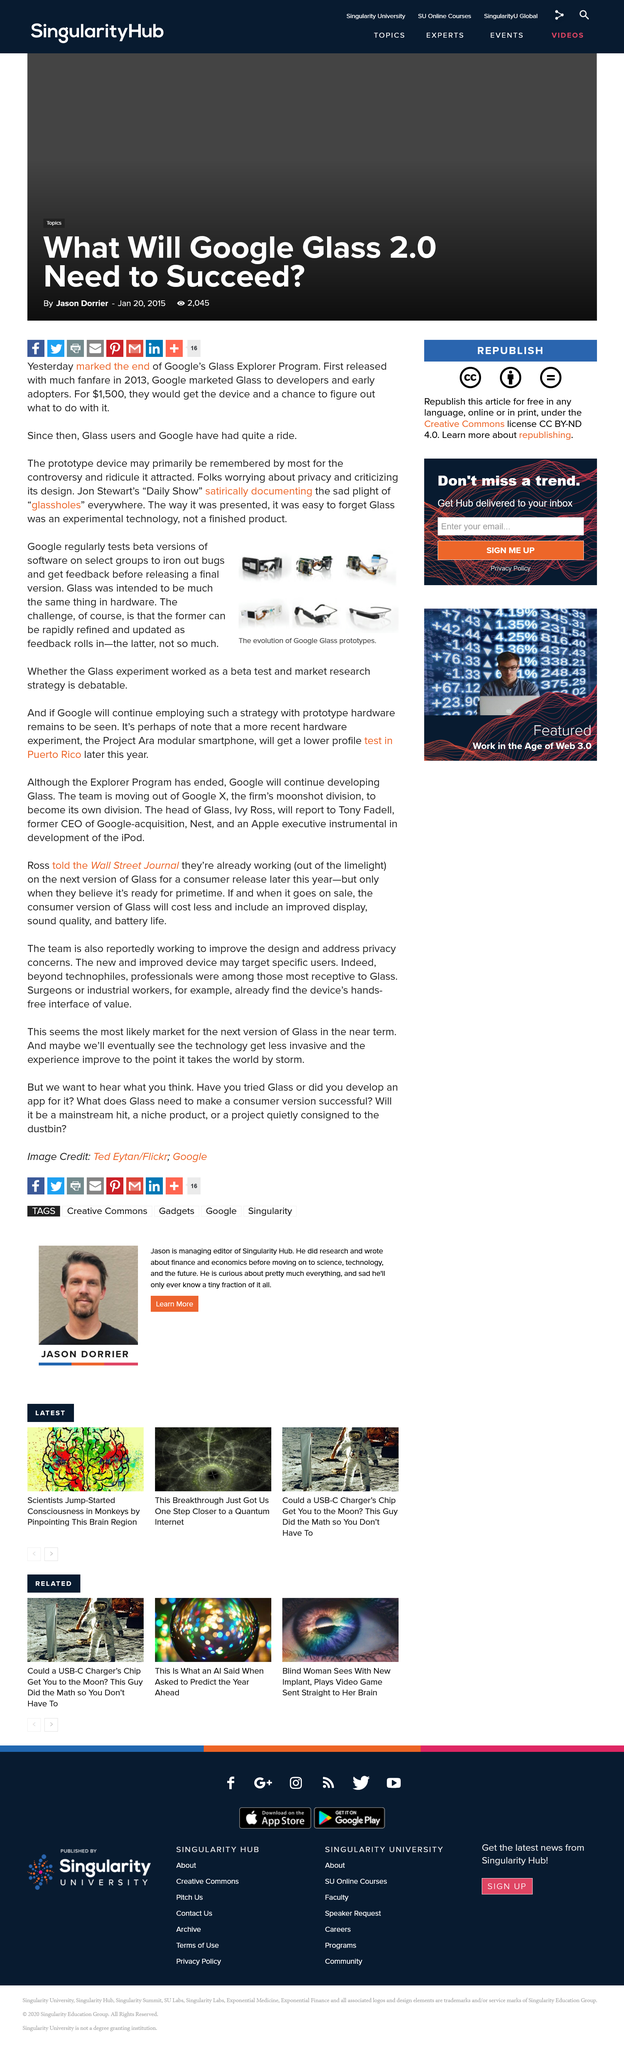Mention a couple of crucial points in this snapshot. Beta testing allows for rapid refinement of software. The Glass experiment was modeled on Google's beta version tests of software. Project Ara will be tested in Puerto Rico later this year. 